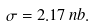<formula> <loc_0><loc_0><loc_500><loc_500>\sigma = 2 . 1 7 \, n b .</formula> 